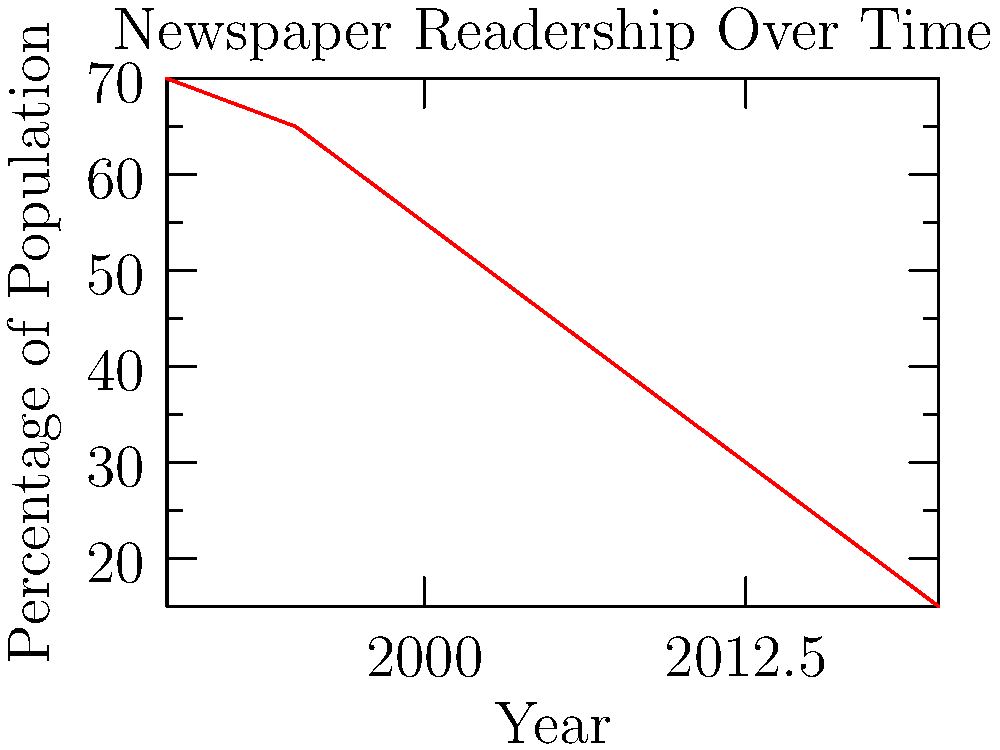Looking at the graph showing the decline of newspaper readership from 1990 to 2020, what was the approximate percentage of the population reading newspapers in 2000? To answer this question, we need to follow these steps:

1. Locate the year 2000 on the x-axis of the graph.
2. Follow the line vertically from 2000 until it intersects with the red line representing newspaper readership.
3. From this intersection point, move horizontally to the left to read the corresponding percentage on the y-axis.

Looking at the graph, we can see that:
- The x-axis represents years from 1990 to 2020.
- The y-axis represents the percentage of the population reading newspapers.
- The red line shows the trend of newspaper readership over time.

For the year 2000, if we follow the vertical line up from the x-axis, it intersects the red line at a point that corresponds to approximately 55% on the y-axis.

Therefore, in 2000, about 55% of the population was reading newspapers.
Answer: 55% 